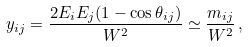<formula> <loc_0><loc_0><loc_500><loc_500>y _ { i j } = \frac { 2 E _ { i } E _ { j } ( 1 - \cos \theta _ { i j } ) } { W ^ { 2 } } \simeq \frac { m _ { i j } } { W ^ { 2 } } \, ,</formula> 